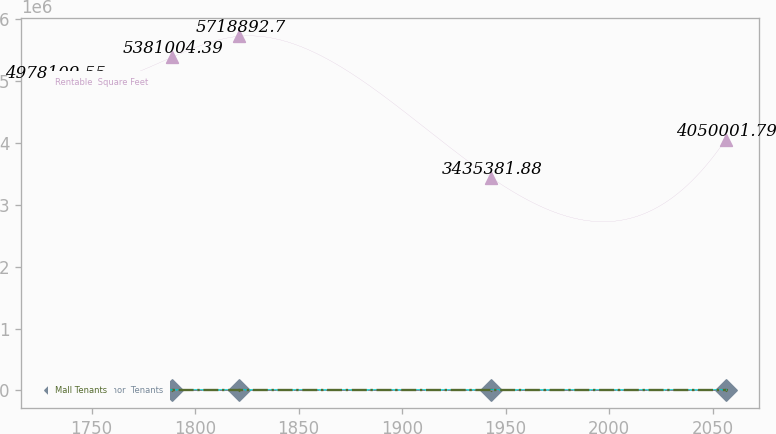<chart> <loc_0><loc_0><loc_500><loc_500><line_chart><ecel><fcel>Rentable  Square Feet<fcel>Occupancy  Rate<fcel>Mall and  Anchor  Tenants<fcel>Mall Tenants<nl><fcel>1732.18<fcel>4.97811e+06<fcel>114.2<fcel>35.03<fcel>15.48<nl><fcel>1788.93<fcel>5.381e+06<fcel>80.53<fcel>27.58<fcel>15.82<nl><fcel>1821.35<fcel>5.71889e+06<fcel>77.03<fcel>31.19<fcel>18.55<nl><fcel>1943.05<fcel>3.43538e+06<fcel>110.7<fcel>29.67<fcel>15.14<nl><fcel>2056.33<fcel>4.05e+06<fcel>90.92<fcel>26.5<fcel>18.15<nl></chart> 